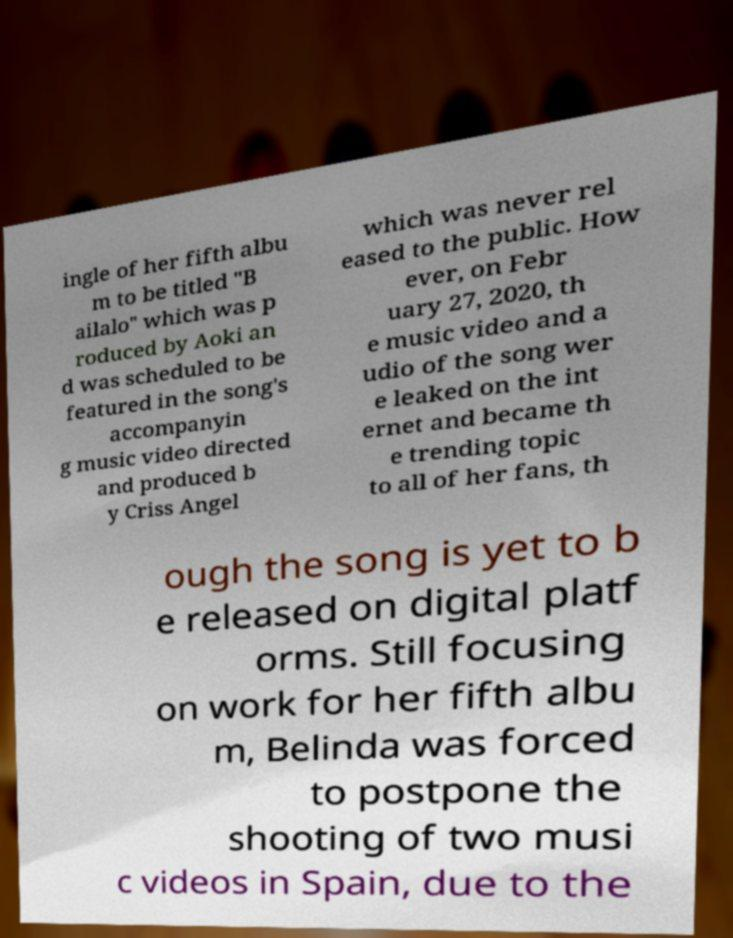I need the written content from this picture converted into text. Can you do that? ingle of her fifth albu m to be titled "B ailalo" which was p roduced by Aoki an d was scheduled to be featured in the song's accompanyin g music video directed and produced b y Criss Angel which was never rel eased to the public. How ever, on Febr uary 27, 2020, th e music video and a udio of the song wer e leaked on the int ernet and became th e trending topic to all of her fans, th ough the song is yet to b e released on digital platf orms. Still focusing on work for her fifth albu m, Belinda was forced to postpone the shooting of two musi c videos in Spain, due to the 